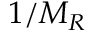<formula> <loc_0><loc_0><loc_500><loc_500>1 / M _ { R }</formula> 